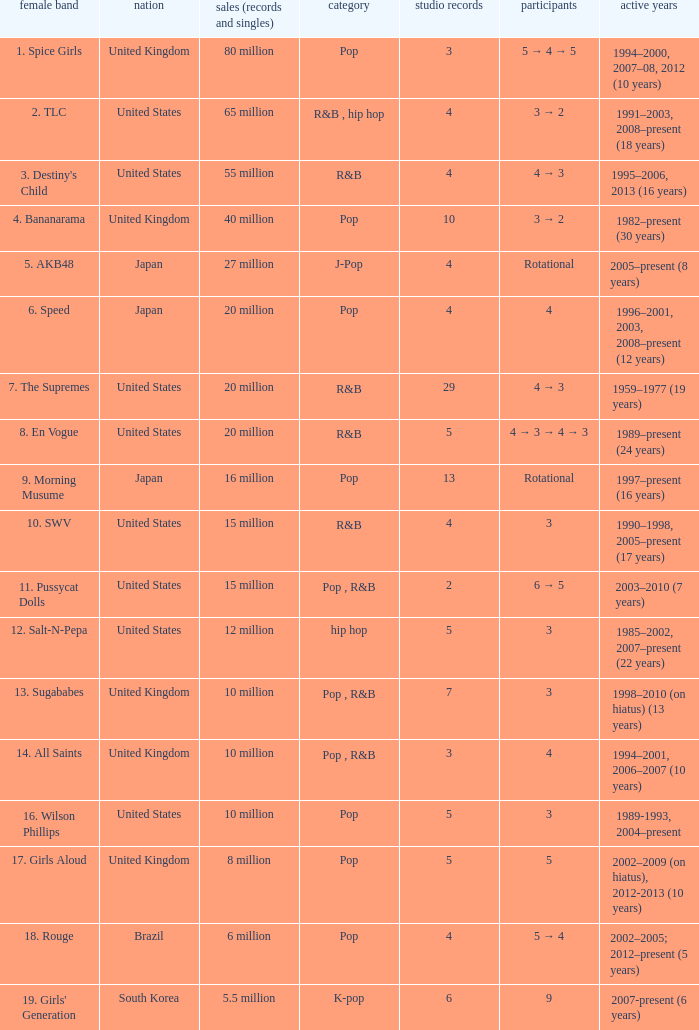How many members were in the group that sold 65 million albums and singles? 3 → 2. 